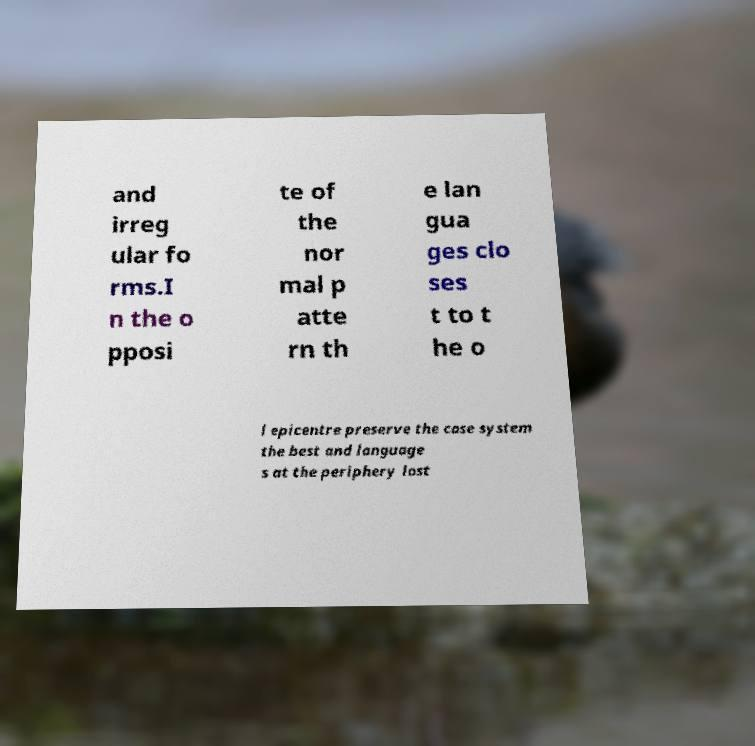I need the written content from this picture converted into text. Can you do that? and irreg ular fo rms.I n the o pposi te of the nor mal p atte rn th e lan gua ges clo ses t to t he o l epicentre preserve the case system the best and language s at the periphery lost 